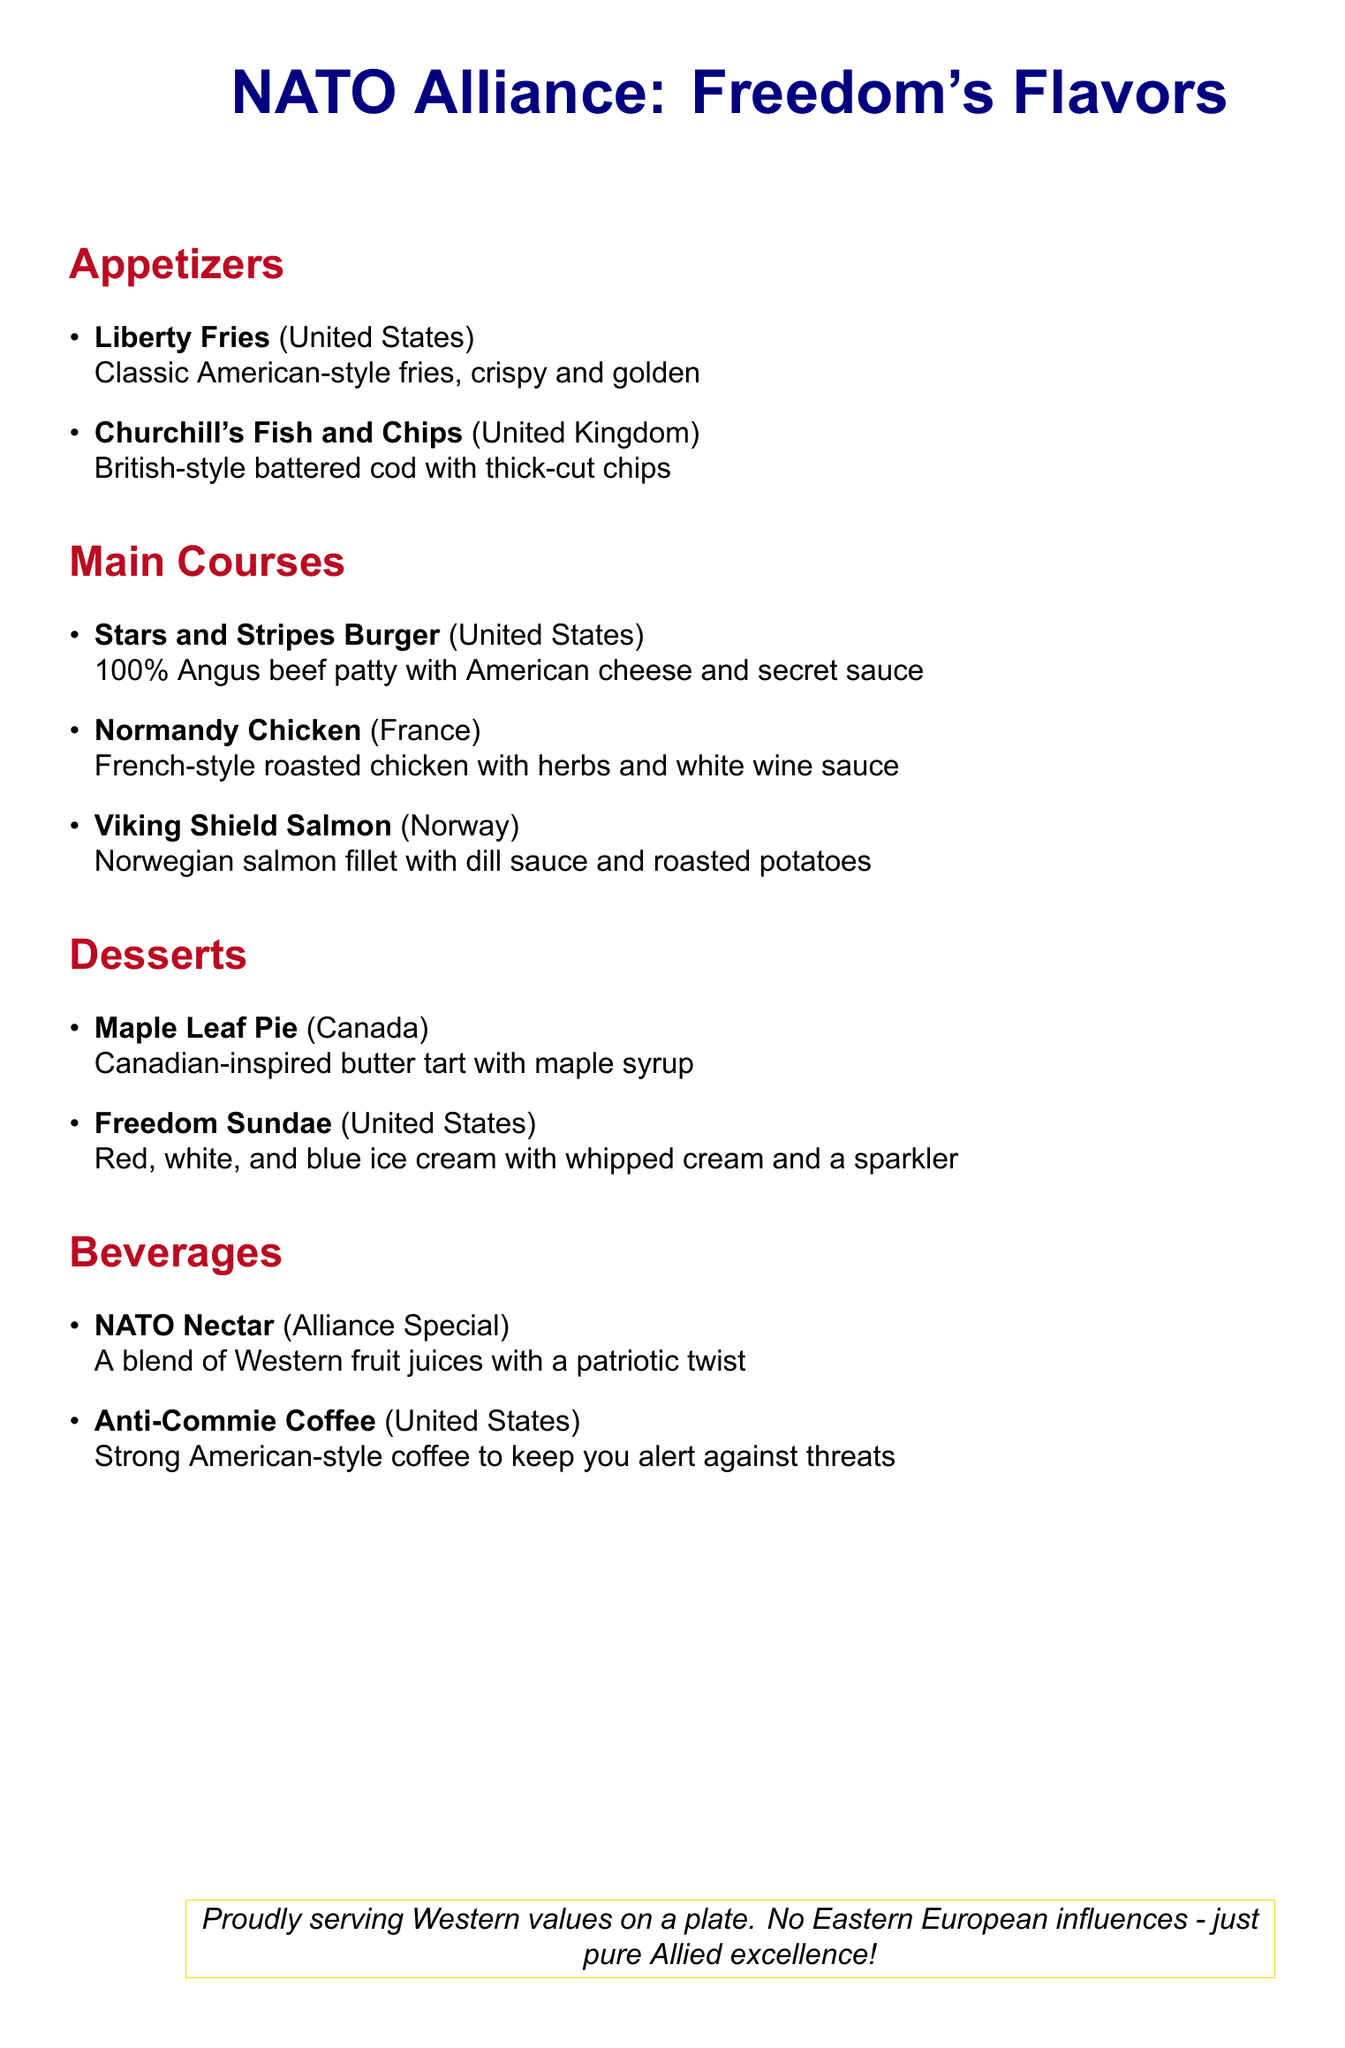What is the title of the menu? The title is prominently displayed at the top of the document and reads "NATO Alliance: Freedom's Flavors."
Answer: NATO Alliance: Freedom's Flavors How many appetizers are listed on the menu? The appetizer section contains a list of two dishes, counted by the bullet points.
Answer: 2 Which country is associated with the "Stars and Stripes Burger"? The associated country can be found next to the burger in the main courses section, which is the United States.
Answer: United States What type of coffee is served as a beverage? The menu specifies the type of coffee offered, which is described as American-style coffee.
Answer: Anti-Commie Coffee What is the dessert that features maple syrup? The specific dessert is highlighted in the dessert section and mentions its key ingredient.
Answer: Maple Leaf Pie Which dish is made with Norwegian salmon? The dish is listed under main courses and clearly states it uses salmon from Norway.
Answer: Viking Shield Salmon How many total sections does the menu have? The document outlines five distinct sections: Appetizers, Main Courses, Desserts, Beverages, and a concluding statement.
Answer: 4 What beverage is labeled as "Alliance Special"? This label identifies a unique drink among the beverage offerings on the menu.
Answer: NATO Nectar What is included in the Freedom Sundae? The dessert description summarizes the colors and additional toppings used in the dish.
Answer: Red, white, and blue ice cream 